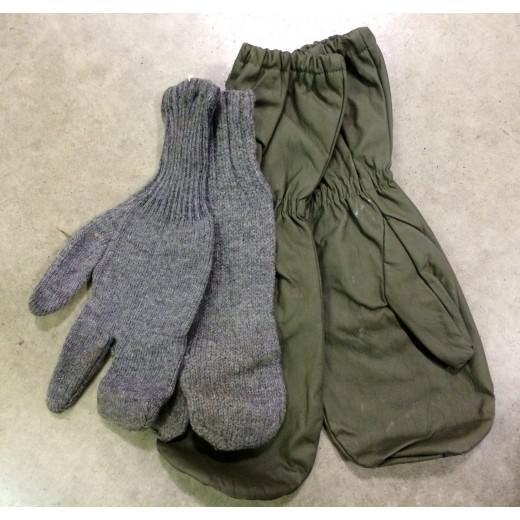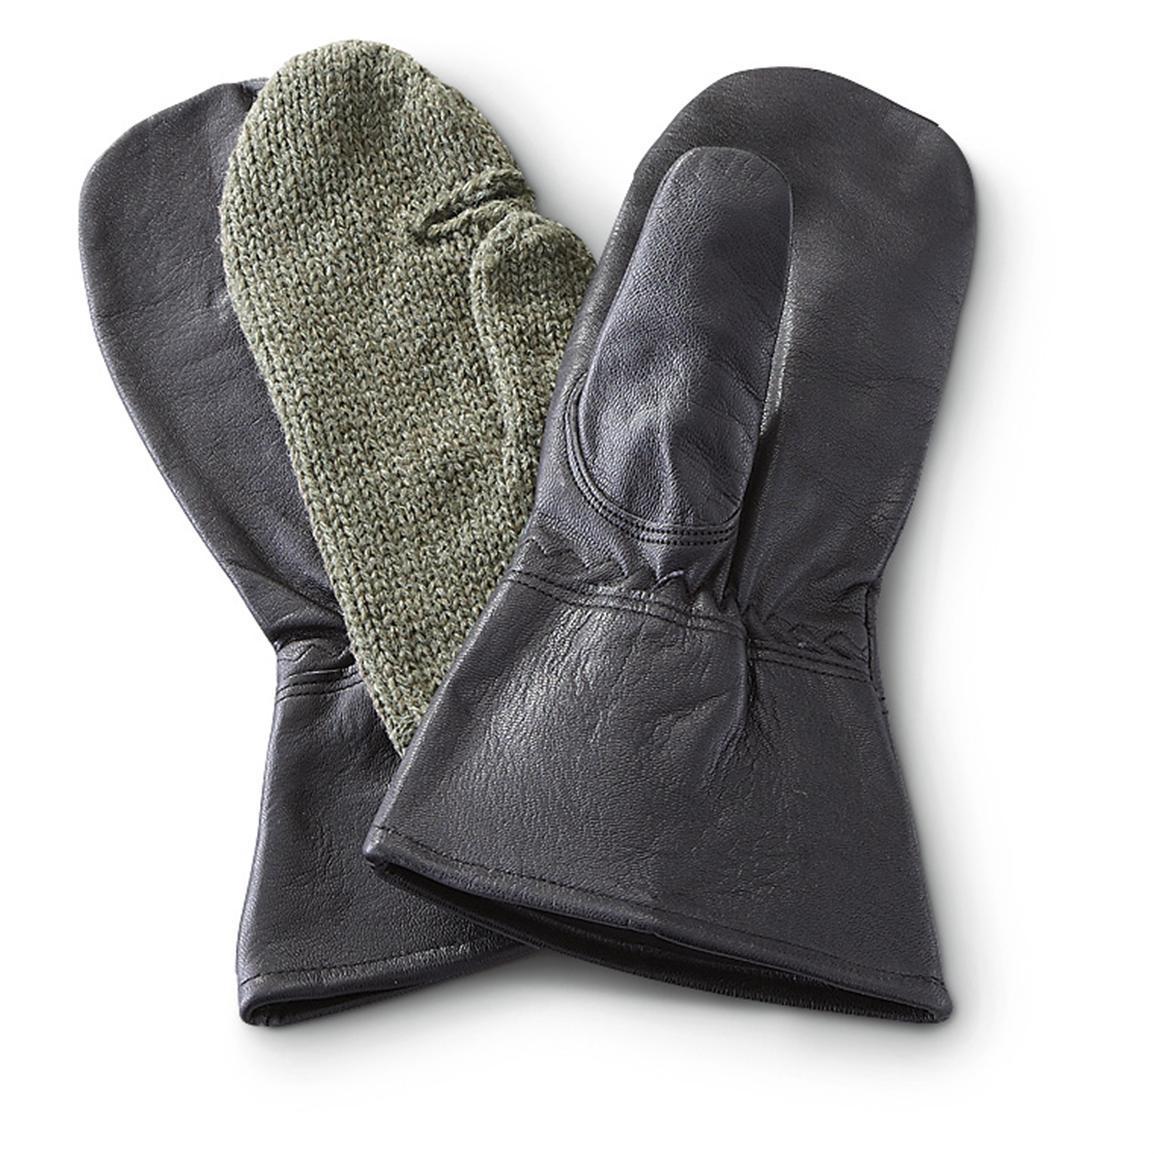The first image is the image on the left, the second image is the image on the right. Considering the images on both sides, is "An image includes a brown knitted hybrid of a mitten and a glove." valid? Answer yes or no. No. 